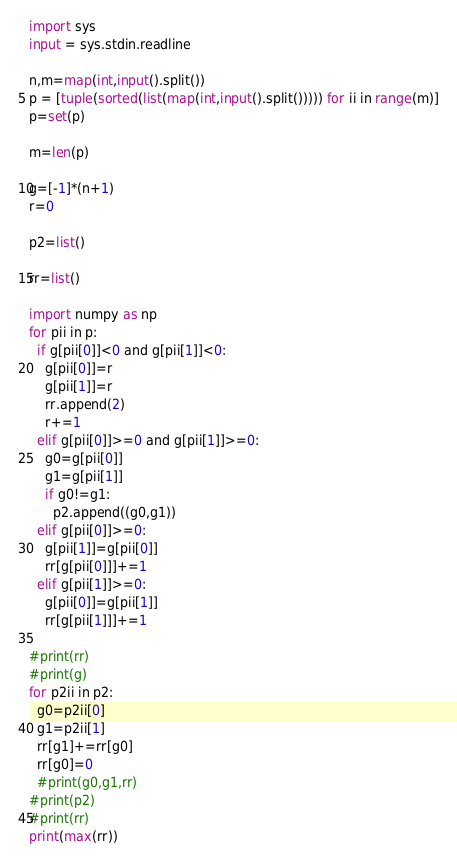Convert code to text. <code><loc_0><loc_0><loc_500><loc_500><_Python_>import sys
input = sys.stdin.readline

n,m=map(int,input().split())
p = [tuple(sorted(list(map(int,input().split())))) for ii in range(m)]
p=set(p)

m=len(p)

g=[-1]*(n+1)
r=0

p2=list()

rr=list()

import numpy as np
for pii in p:
  if g[pii[0]]<0 and g[pii[1]]<0:
    g[pii[0]]=r
    g[pii[1]]=r
    rr.append(2)
    r+=1
  elif g[pii[0]]>=0 and g[pii[1]]>=0:
    g0=g[pii[0]]
    g1=g[pii[1]]
    if g0!=g1:
      p2.append((g0,g1))
  elif g[pii[0]]>=0:
    g[pii[1]]=g[pii[0]]
    rr[g[pii[0]]]+=1
  elif g[pii[1]]>=0:
    g[pii[0]]=g[pii[1]]
    rr[g[pii[1]]]+=1

#print(rr)
#print(g)
for p2ii in p2:
  g0=p2ii[0]
  g1=p2ii[1]
  rr[g1]+=rr[g0]
  rr[g0]=0
  #print(g0,g1,rr)
#print(p2)
#print(rr)
print(max(rr))</code> 